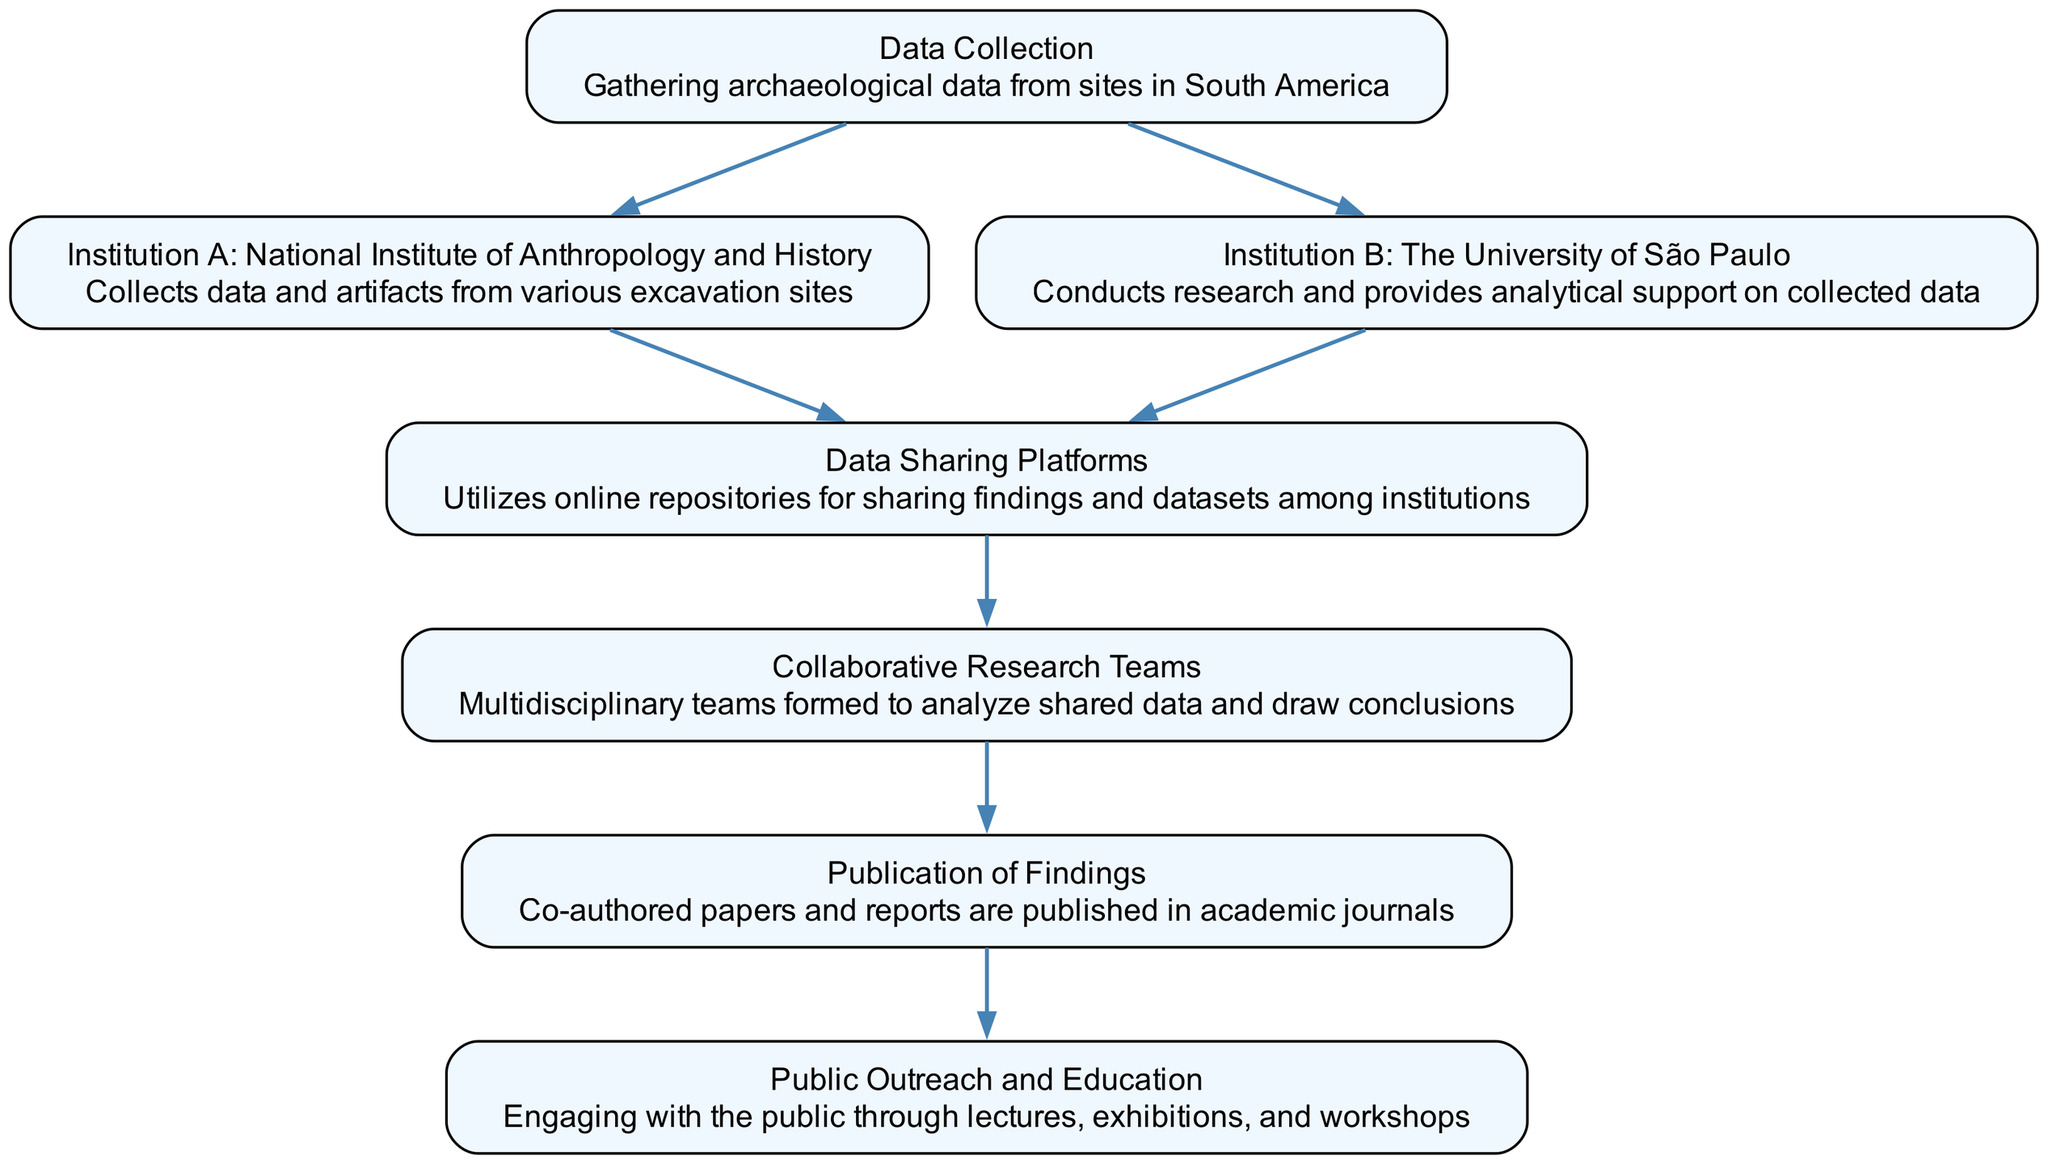What is the first step in the flow of information? The first step is "Data Collection," where archaeological data is gathered from sites in South America. This is the starting node of the flowchart and is indicated without any incoming connections.
Answer: Data Collection How many institutions are involved in the data collection process? There are two institutions involved in the data collection process: "Institution A: National Institute of Anthropology and History" and "Institution B: The University of São Paulo." Both institutions are connected directly to the "Data Collection" node.
Answer: Two What types of teams are formed after data is shared? The types of teams formed after data is shared are called "Collaborative Research Teams," which consist of multidisciplinary teams that analyze shared data. This is a result of the connection from "Data Sharing Platforms."
Answer: Collaborative Research Teams Which institutions share their findings through online platforms? Both "Institution A: National Institute of Anthropology and History" and "Institution B: The University of São Paulo" share their findings through "Data Sharing Platforms." This is seen as both institutions are connected to the node representing data sharing.
Answer: Institution A and Institution B What is the final outcome of the collaborative research process? The final outcome is the "Publication of Findings," where co-authored papers and reports are published in academic journals. This node is linked from the "Collaborative Research Teams" node, representing the culmination of their efforts.
Answer: Publication of Findings What is the role of "Public Outreach and Education"? The role of "Public Outreach and Education" is to engage with the public through lectures, exhibitions, and workshops. This step follows from the publication of findings, indicating a process of sharing knowledge with the community.
Answer: Engage with the public How many edges are there in the diagram? There are six edges in the diagram, which represent the connections between various nodes illustrating the flow of information across the collaborative process.
Answer: Six What happens immediately after data sharing? Immediately after data sharing, "Collaborative Research Teams" are formed to analyze the shared data and draw conclusions, indicating a teamwork approach to archaeology research.
Answer: Collaborative Research Teams What is the connection between "Publication of Findings" and "Public Outreach and Education"? The connection is that "Publication of Findings" leads directly to "Public Outreach and Education," indicating that published research is intended for public engagement and dissemination.
Answer: Leads directly to 